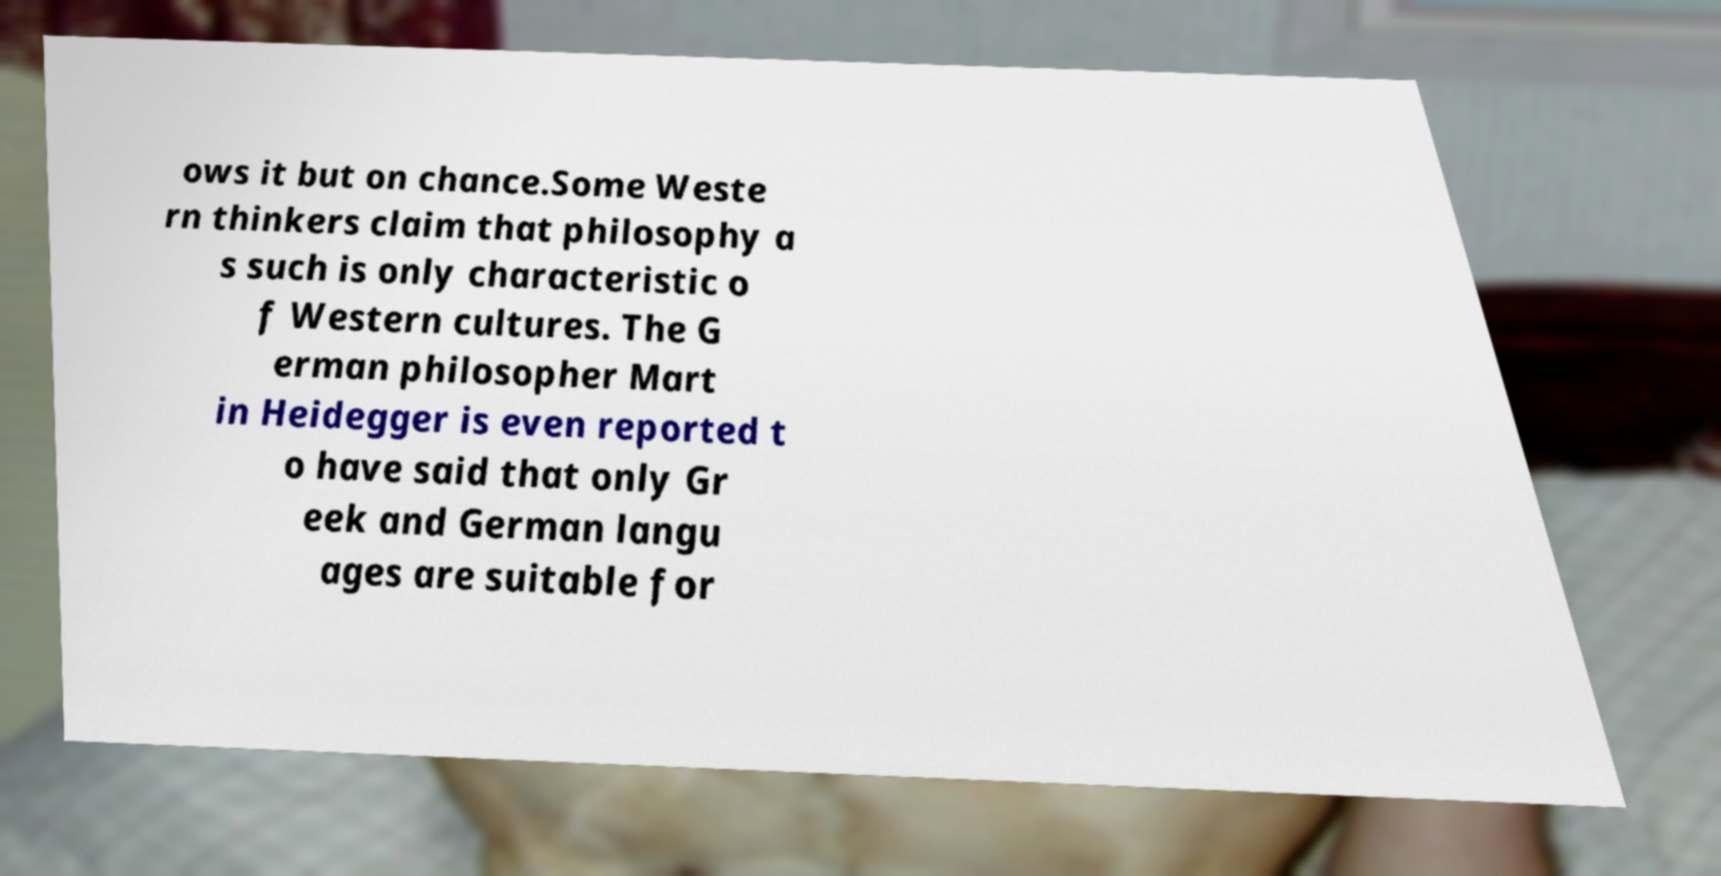Can you read and provide the text displayed in the image?This photo seems to have some interesting text. Can you extract and type it out for me? ows it but on chance.Some Weste rn thinkers claim that philosophy a s such is only characteristic o f Western cultures. The G erman philosopher Mart in Heidegger is even reported t o have said that only Gr eek and German langu ages are suitable for 